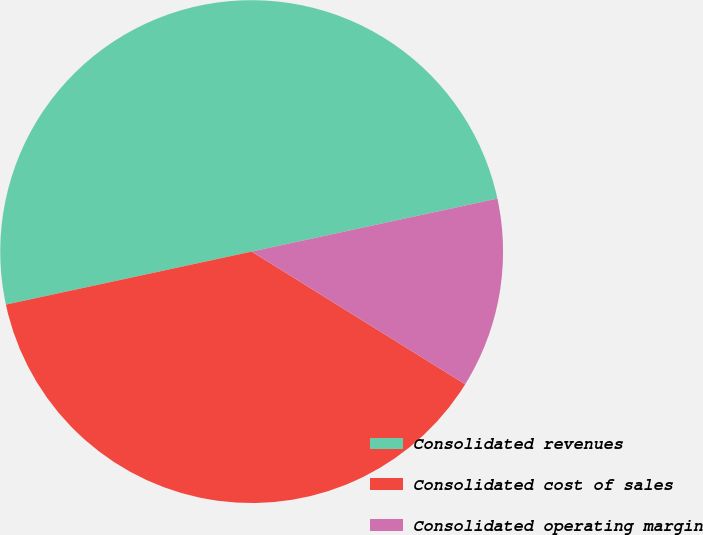Convert chart. <chart><loc_0><loc_0><loc_500><loc_500><pie_chart><fcel>Consolidated revenues<fcel>Consolidated cost of sales<fcel>Consolidated operating margin<nl><fcel>50.0%<fcel>37.77%<fcel>12.23%<nl></chart> 